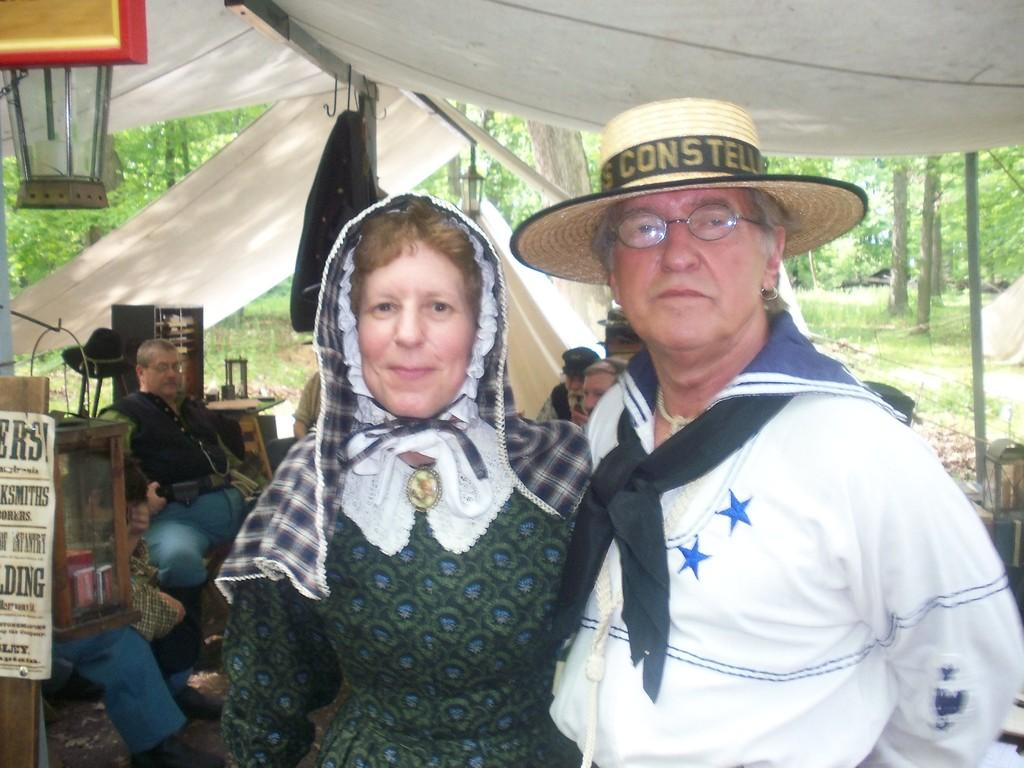Who are the two people in the center of the image? There is a man and a woman in the center of the image. What are they standing under? They are standing under a tent. What can be seen in the background of the image? There are people sitting in the background of the image. What type of natural environment is visible in the image? The image contains many trees. What type of sail can be seen in the image? There is no sail present in the image. What kind of bait is being used by the people sitting in the background? There is no fishing or baiting activity depicted in the image. 